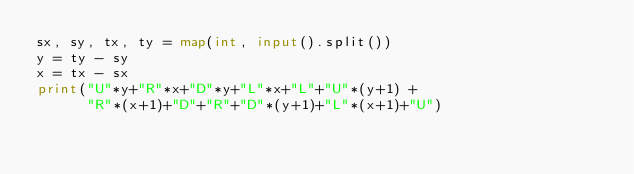Convert code to text. <code><loc_0><loc_0><loc_500><loc_500><_Python_>sx, sy, tx, ty = map(int, input().split())
y = ty - sy
x = tx - sx
print("U"*y+"R"*x+"D"*y+"L"*x+"L"+"U"*(y+1) +
      "R"*(x+1)+"D"+"R"+"D"*(y+1)+"L"*(x+1)+"U")</code> 